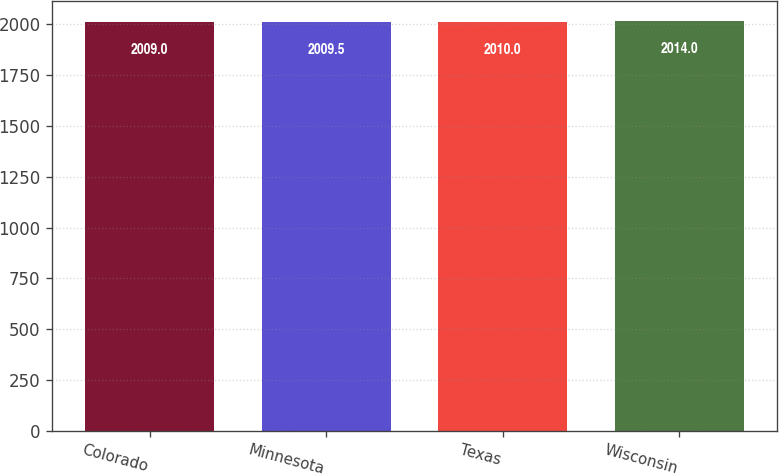<chart> <loc_0><loc_0><loc_500><loc_500><bar_chart><fcel>Colorado<fcel>Minnesota<fcel>Texas<fcel>Wisconsin<nl><fcel>2009<fcel>2009.5<fcel>2010<fcel>2014<nl></chart> 